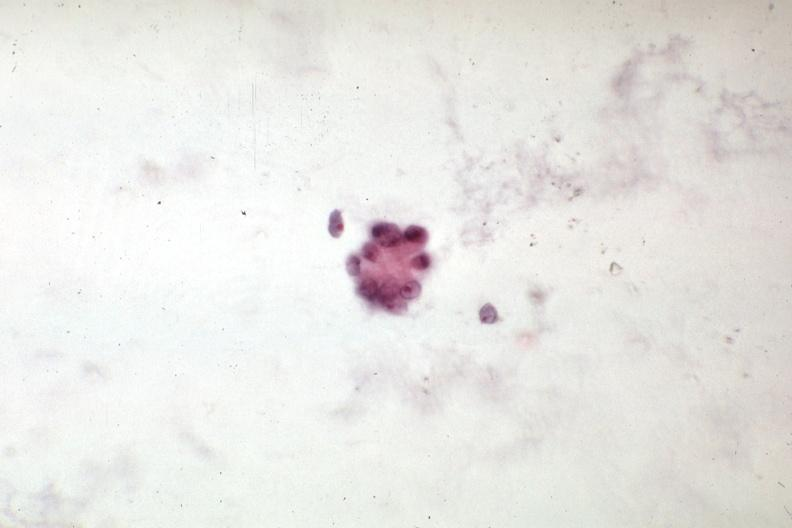s abdomen present?
Answer the question using a single word or phrase. Yes 